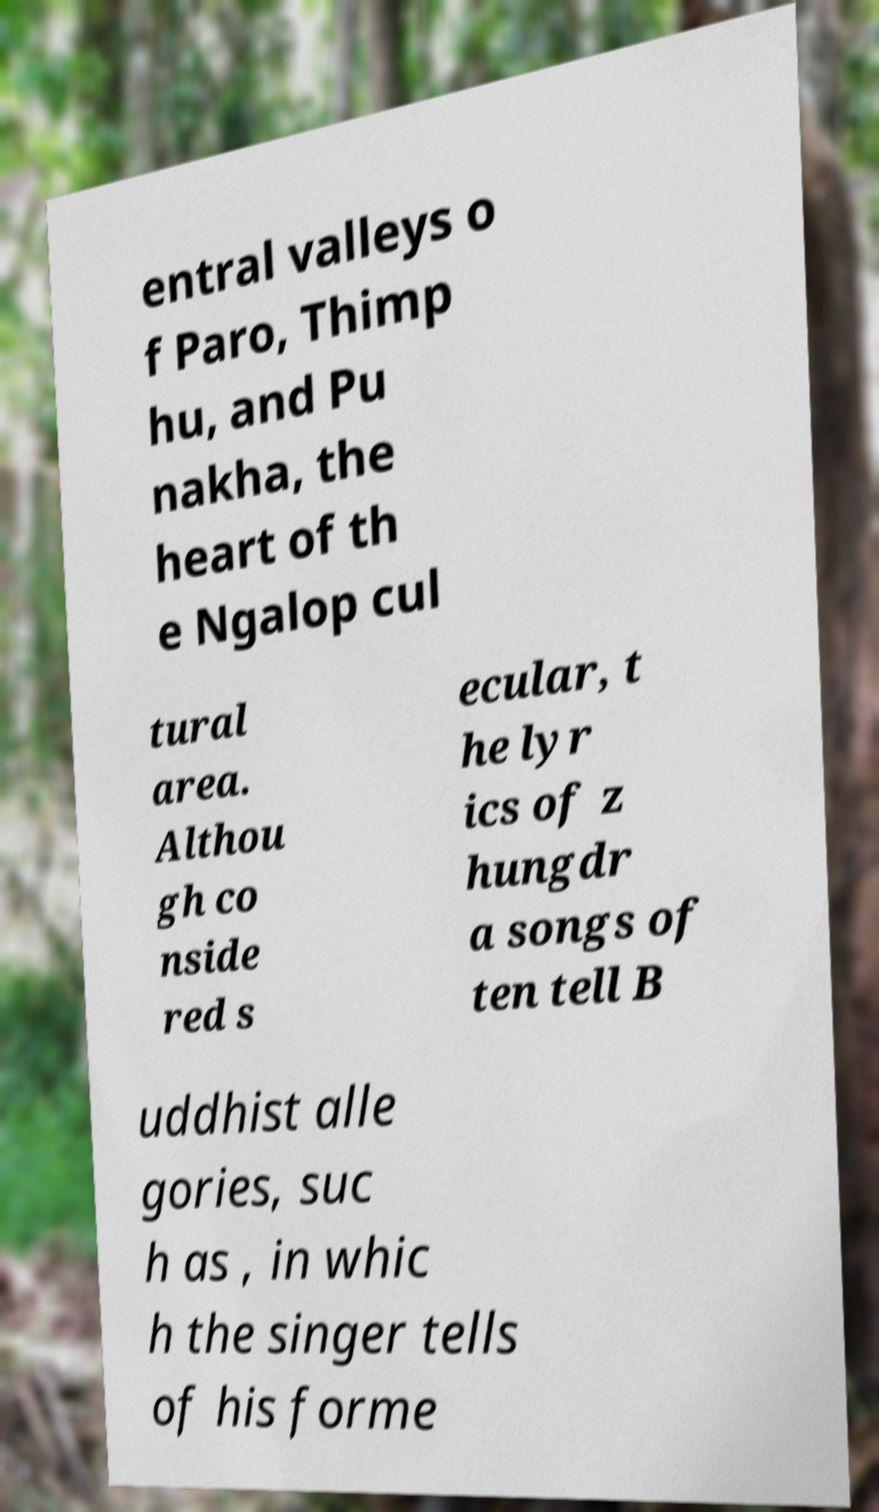There's text embedded in this image that I need extracted. Can you transcribe it verbatim? entral valleys o f Paro, Thimp hu, and Pu nakha, the heart of th e Ngalop cul tural area. Althou gh co nside red s ecular, t he lyr ics of z hungdr a songs of ten tell B uddhist alle gories, suc h as , in whic h the singer tells of his forme 